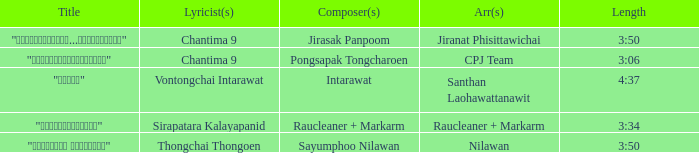Who was the arranger for the song that had a lyricist of Sirapatara Kalayapanid? Raucleaner + Markarm. 